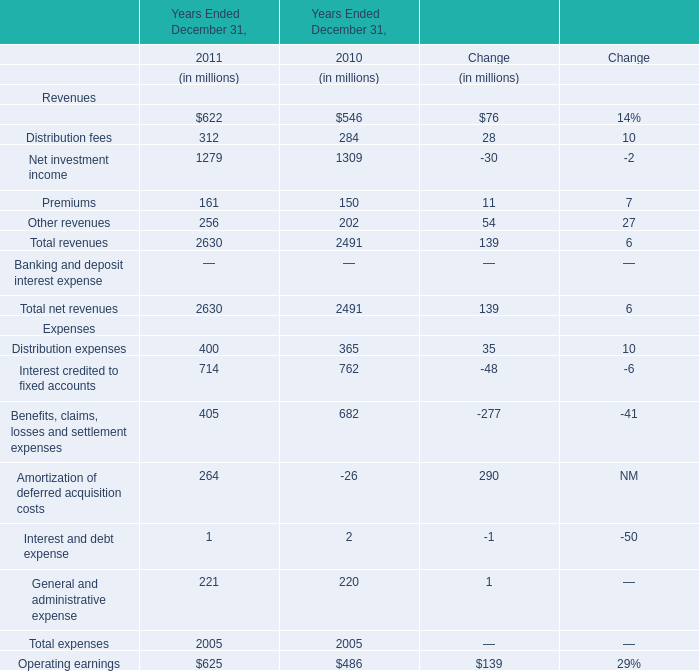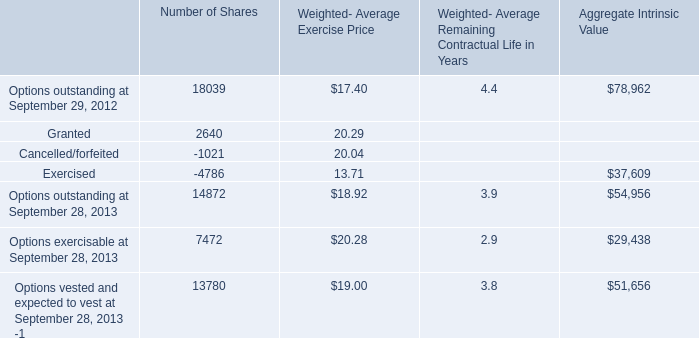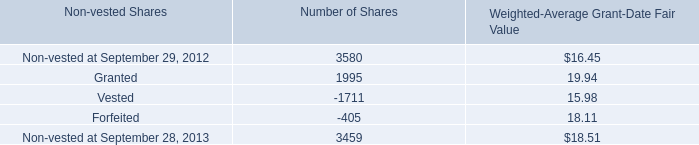What is the total amount of Options outstanding at September 28, 2013 of Number of Shares, and Vested of Number of Shares ? 
Computations: (14872.0 + 1711.0)
Answer: 16583.0. 